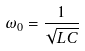Convert formula to latex. <formula><loc_0><loc_0><loc_500><loc_500>\omega _ { 0 } = \frac { 1 } { \sqrt { L C } }</formula> 